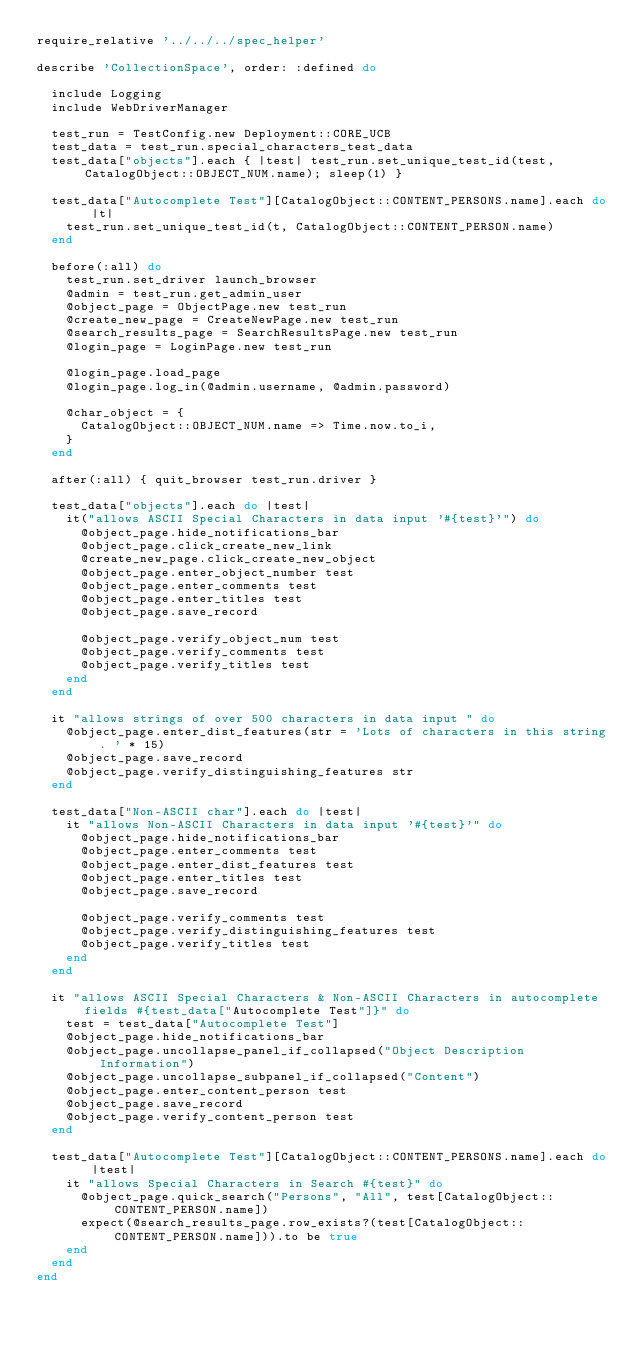<code> <loc_0><loc_0><loc_500><loc_500><_Ruby_>require_relative '../../../spec_helper'

describe 'CollectionSpace', order: :defined do

  include Logging
  include WebDriverManager

  test_run = TestConfig.new Deployment::CORE_UCB
  test_data = test_run.special_characters_test_data
  test_data["objects"].each { |test| test_run.set_unique_test_id(test, CatalogObject::OBJECT_NUM.name); sleep(1) }

  test_data["Autocomplete Test"][CatalogObject::CONTENT_PERSONS.name].each do |t|
    test_run.set_unique_test_id(t, CatalogObject::CONTENT_PERSON.name)
  end

  before(:all) do
    test_run.set_driver launch_browser
    @admin = test_run.get_admin_user
    @object_page = ObjectPage.new test_run
    @create_new_page = CreateNewPage.new test_run
    @search_results_page = SearchResultsPage.new test_run
    @login_page = LoginPage.new test_run

    @login_page.load_page
    @login_page.log_in(@admin.username, @admin.password)

    @char_object = {
      CatalogObject::OBJECT_NUM.name => Time.now.to_i,
    }
  end

  after(:all) { quit_browser test_run.driver }

  test_data["objects"].each do |test|
    it("allows ASCII Special Characters in data input '#{test}'") do
      @object_page.hide_notifications_bar
      @object_page.click_create_new_link
      @create_new_page.click_create_new_object
      @object_page.enter_object_number test
      @object_page.enter_comments test
      @object_page.enter_titles test
      @object_page.save_record

      @object_page.verify_object_num test
      @object_page.verify_comments test
      @object_page.verify_titles test
    end
  end

  it "allows strings of over 500 characters in data input " do
    @object_page.enter_dist_features(str = 'Lots of characters in this string. ' * 15)
    @object_page.save_record
    @object_page.verify_distinguishing_features str
  end

  test_data["Non-ASCII char"].each do |test|
    it "allows Non-ASCII Characters in data input '#{test}'" do
      @object_page.hide_notifications_bar
      @object_page.enter_comments test
      @object_page.enter_dist_features test
      @object_page.enter_titles test
      @object_page.save_record

      @object_page.verify_comments test
      @object_page.verify_distinguishing_features test
      @object_page.verify_titles test
    end
  end

  it "allows ASCII Special Characters & Non-ASCII Characters in autocomplete fields #{test_data["Autocomplete Test"]}" do
    test = test_data["Autocomplete Test"]
    @object_page.hide_notifications_bar
    @object_page.uncollapse_panel_if_collapsed("Object Description Information")
    @object_page.uncollapse_subpanel_if_collapsed("Content")
    @object_page.enter_content_person test
    @object_page.save_record
    @object_page.verify_content_person test
  end

  test_data["Autocomplete Test"][CatalogObject::CONTENT_PERSONS.name].each do |test|
    it "allows Special Characters in Search #{test}" do
      @object_page.quick_search("Persons", "All", test[CatalogObject::CONTENT_PERSON.name])
      expect(@search_results_page.row_exists?(test[CatalogObject::CONTENT_PERSON.name])).to be true
    end
  end
end
</code> 